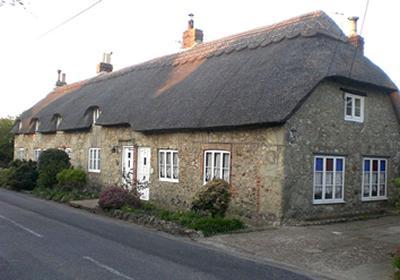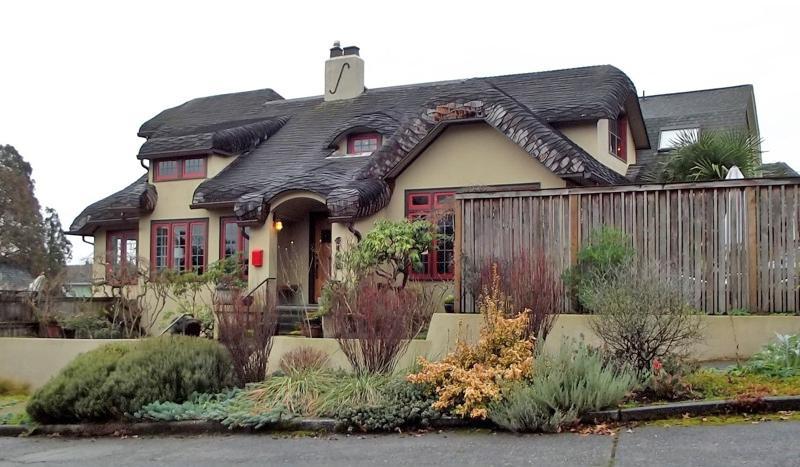The first image is the image on the left, the second image is the image on the right. Evaluate the accuracy of this statement regarding the images: "One of these is an open canopy over a deck area - it's not for dwelling, cooking, or sleeping.". Is it true? Answer yes or no. No. The first image is the image on the left, the second image is the image on the right. Evaluate the accuracy of this statement regarding the images: "The left image includes a peaked thatch roof with an even bottom edge and a gray cap on its tip, held up by corner posts.". Is it true? Answer yes or no. No. 